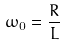<formula> <loc_0><loc_0><loc_500><loc_500>\omega _ { 0 } = \frac { R } { L }</formula> 